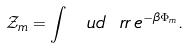<formula> <loc_0><loc_0><loc_500><loc_500>\mathcal { Z } _ { m } = \int \, \ u d \ r r \, e ^ { - \beta \Phi _ { m } } .</formula> 